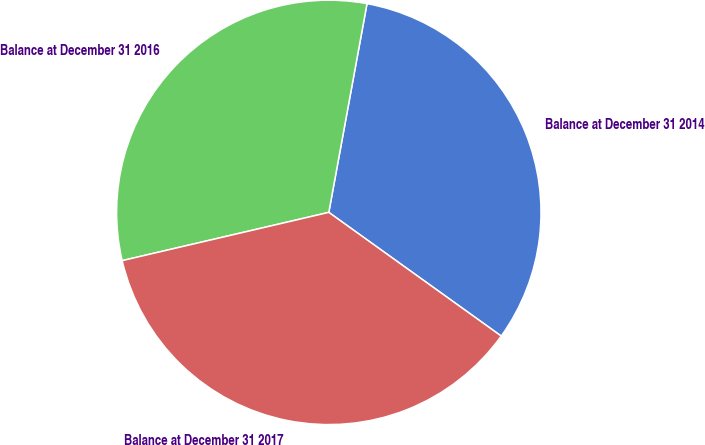<chart> <loc_0><loc_0><loc_500><loc_500><pie_chart><fcel>Balance at December 31 2014<fcel>Balance at December 31 2016<fcel>Balance at December 31 2017<nl><fcel>32.02%<fcel>31.53%<fcel>36.44%<nl></chart> 